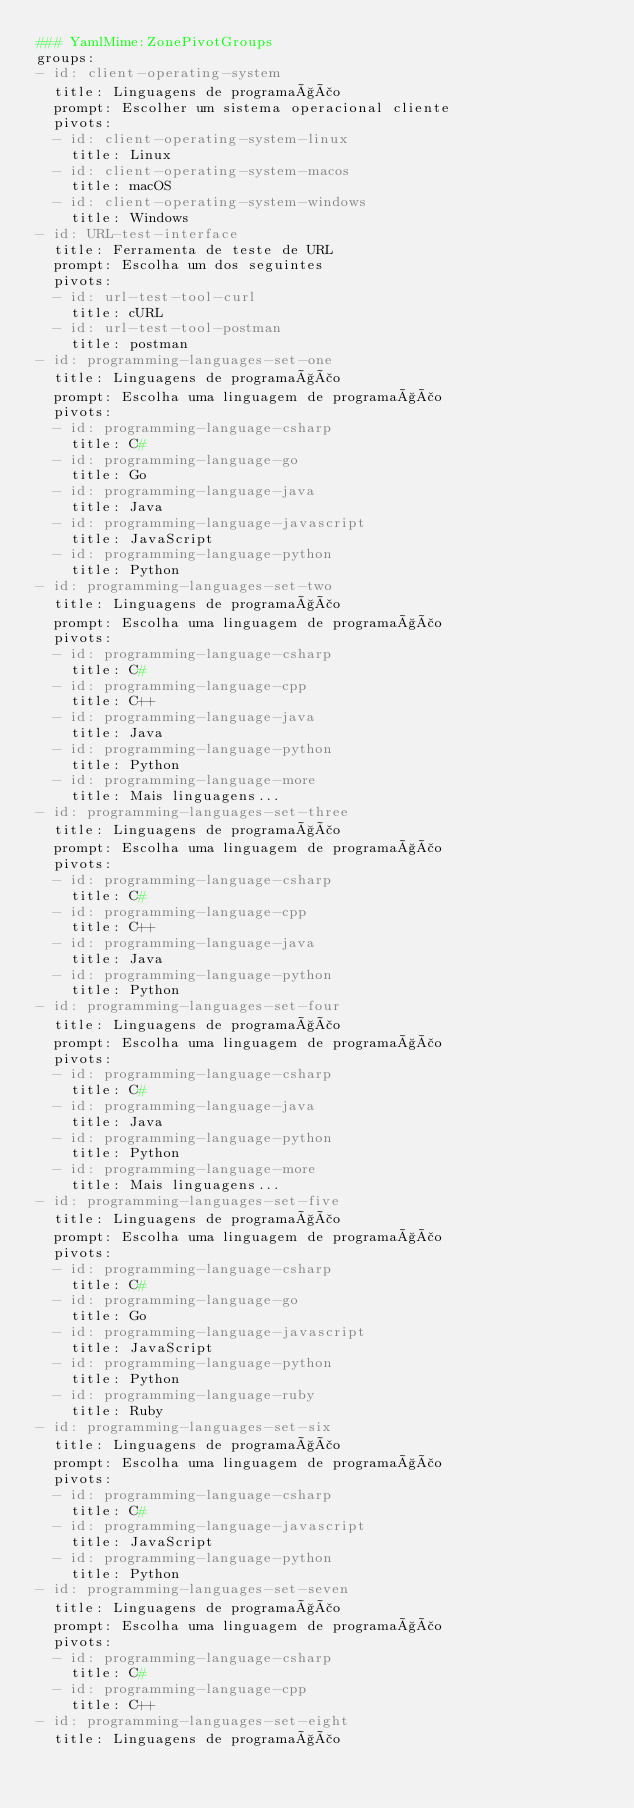Convert code to text. <code><loc_0><loc_0><loc_500><loc_500><_YAML_>### YamlMime:ZonePivotGroups
groups:
- id: client-operating-system
  title: Linguagens de programação
  prompt: Escolher um sistema operacional cliente
  pivots:
  - id: client-operating-system-linux
    title: Linux
  - id: client-operating-system-macos
    title: macOS
  - id: client-operating-system-windows
    title: Windows
- id: URL-test-interface
  title: Ferramenta de teste de URL
  prompt: Escolha um dos seguintes
  pivots:
  - id: url-test-tool-curl
    title: cURL
  - id: url-test-tool-postman
    title: postman
- id: programming-languages-set-one
  title: Linguagens de programação
  prompt: Escolha uma linguagem de programação
  pivots:
  - id: programming-language-csharp
    title: C#
  - id: programming-language-go
    title: Go
  - id: programming-language-java
    title: Java
  - id: programming-language-javascript
    title: JavaScript
  - id: programming-language-python
    title: Python
- id: programming-languages-set-two
  title: Linguagens de programação
  prompt: Escolha uma linguagem de programação
  pivots:
  - id: programming-language-csharp
    title: C#
  - id: programming-language-cpp
    title: C++
  - id: programming-language-java
    title: Java
  - id: programming-language-python
    title: Python
  - id: programming-language-more
    title: Mais linguagens...
- id: programming-languages-set-three
  title: Linguagens de programação
  prompt: Escolha uma linguagem de programação
  pivots:
  - id: programming-language-csharp
    title: C#
  - id: programming-language-cpp
    title: C++
  - id: programming-language-java
    title: Java
  - id: programming-language-python
    title: Python
- id: programming-languages-set-four
  title: Linguagens de programação
  prompt: Escolha uma linguagem de programação
  pivots:
  - id: programming-language-csharp
    title: C#
  - id: programming-language-java
    title: Java
  - id: programming-language-python
    title: Python
  - id: programming-language-more
    title: Mais linguagens...
- id: programming-languages-set-five
  title: Linguagens de programação
  prompt: Escolha uma linguagem de programação
  pivots:
  - id: programming-language-csharp
    title: C#
  - id: programming-language-go
    title: Go
  - id: programming-language-javascript
    title: JavaScript
  - id: programming-language-python
    title: Python
  - id: programming-language-ruby
    title: Ruby
- id: programming-languages-set-six
  title: Linguagens de programação
  prompt: Escolha uma linguagem de programação
  pivots:
  - id: programming-language-csharp
    title: C#
  - id: programming-language-javascript
    title: JavaScript
  - id: programming-language-python
    title: Python
- id: programming-languages-set-seven
  title: Linguagens de programação
  prompt: Escolha uma linguagem de programação
  pivots:
  - id: programming-language-csharp
    title: C#
  - id: programming-language-cpp
    title: C++
- id: programming-languages-set-eight
  title: Linguagens de programação</code> 